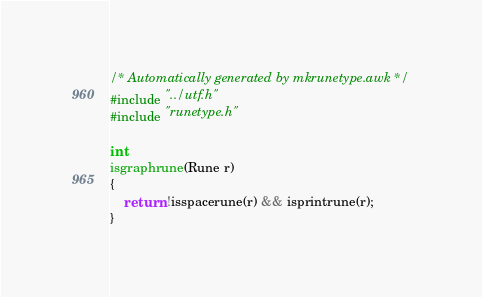Convert code to text. <code><loc_0><loc_0><loc_500><loc_500><_C_>/* Automatically generated by mkrunetype.awk */
#include "../utf.h"
#include "runetype.h"

int
isgraphrune(Rune r)
{
	return !isspacerune(r) && isprintrune(r);
}
</code> 